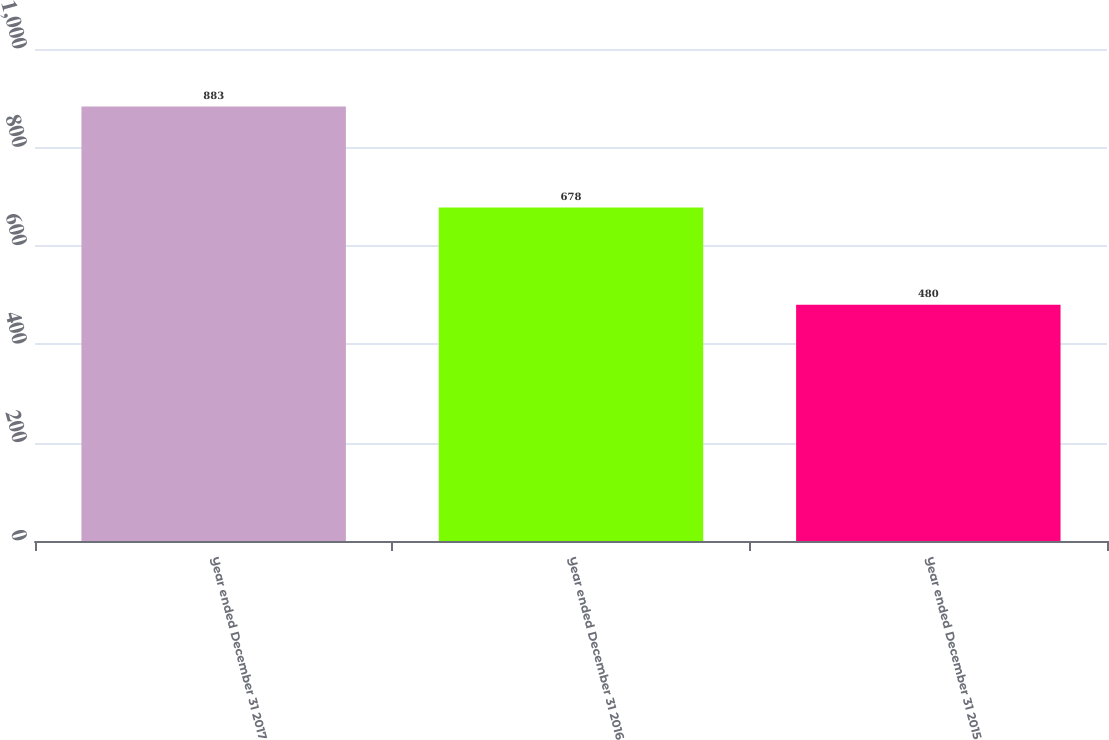Convert chart. <chart><loc_0><loc_0><loc_500><loc_500><bar_chart><fcel>Year ended December 31 2017<fcel>Year ended December 31 2016<fcel>Year ended December 31 2015<nl><fcel>883<fcel>678<fcel>480<nl></chart> 